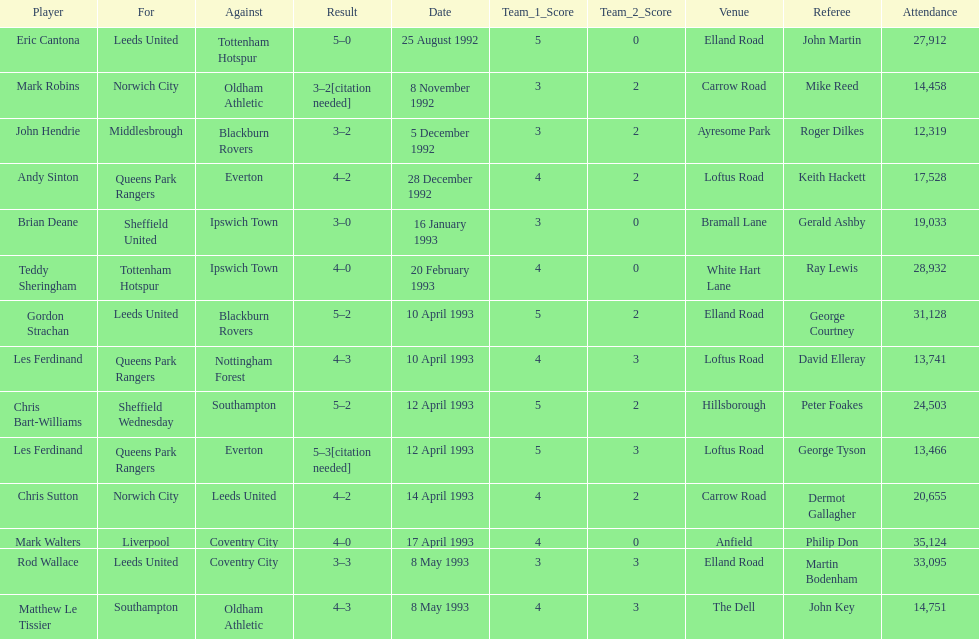Who does john hendrie play for? Middlesbrough. 